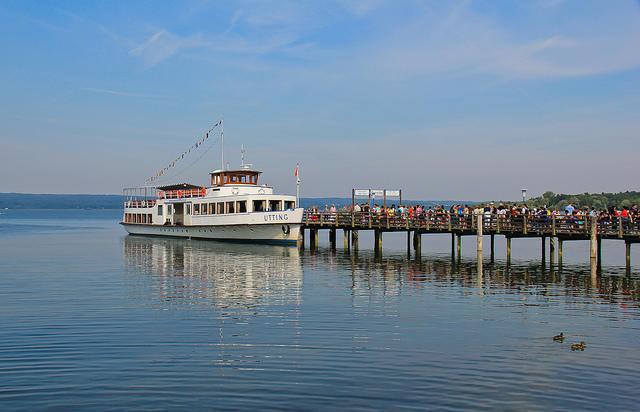How many birds are in the picture?
Give a very brief answer. 2. How many boats are there?
Give a very brief answer. 1. How many boats can you count?
Give a very brief answer. 1. How many people can you see?
Give a very brief answer. 1. 